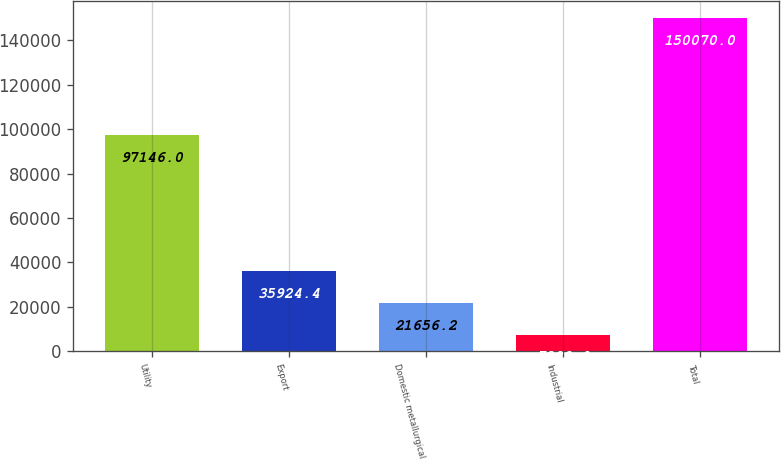Convert chart to OTSL. <chart><loc_0><loc_0><loc_500><loc_500><bar_chart><fcel>Utility<fcel>Export<fcel>Domestic metallurgical<fcel>Industrial<fcel>Total<nl><fcel>97146<fcel>35924.4<fcel>21656.2<fcel>7388<fcel>150070<nl></chart> 